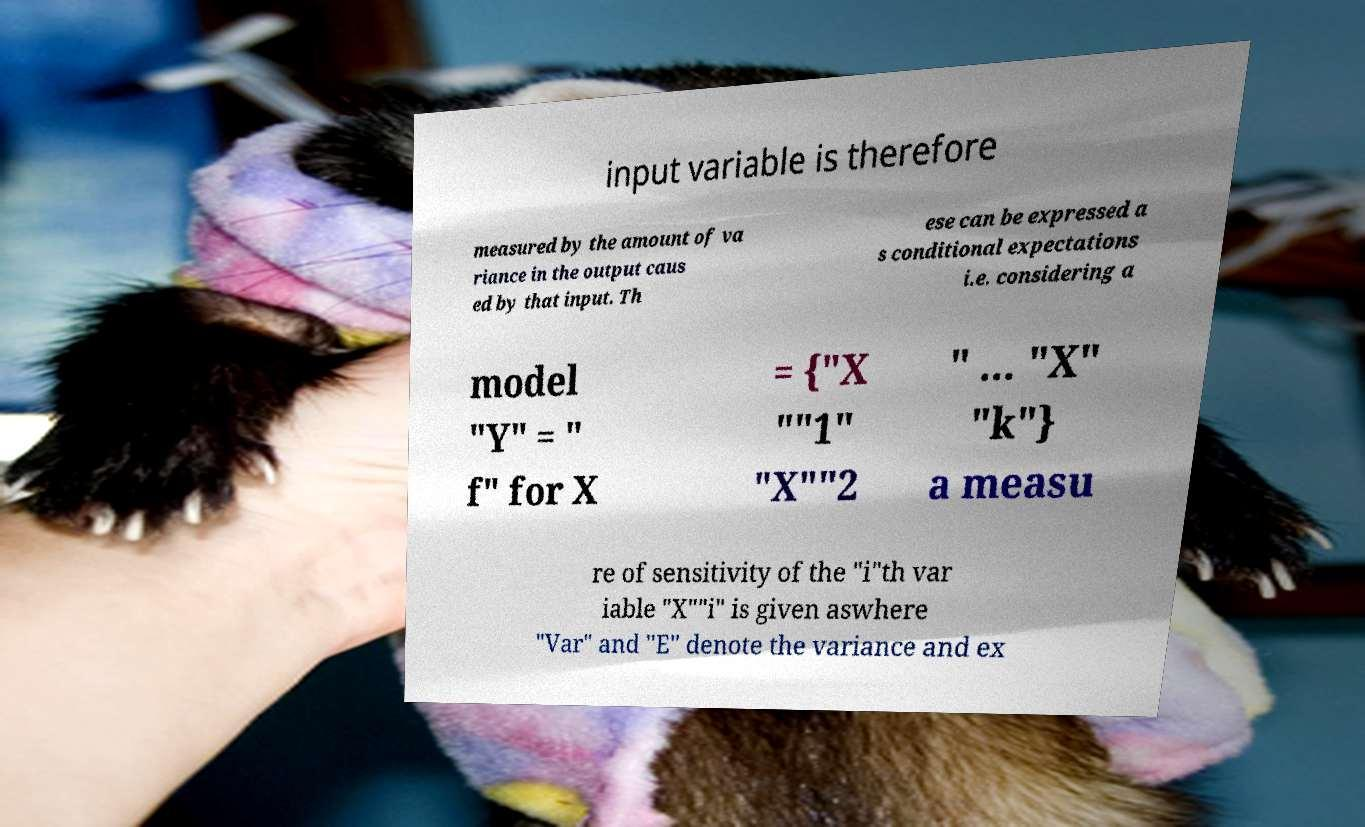Could you assist in decoding the text presented in this image and type it out clearly? input variable is therefore measured by the amount of va riance in the output caus ed by that input. Th ese can be expressed a s conditional expectations i.e. considering a model "Y" = " f" for X = {"X ""1" "X""2 " ... "X" "k"} a measu re of sensitivity of the "i"th var iable "X""i" is given aswhere "Var" and "E" denote the variance and ex 